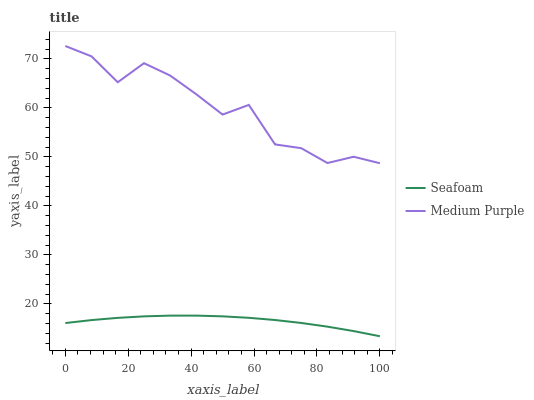Does Seafoam have the maximum area under the curve?
Answer yes or no. No. Is Seafoam the roughest?
Answer yes or no. No. Does Seafoam have the highest value?
Answer yes or no. No. Is Seafoam less than Medium Purple?
Answer yes or no. Yes. Is Medium Purple greater than Seafoam?
Answer yes or no. Yes. Does Seafoam intersect Medium Purple?
Answer yes or no. No. 